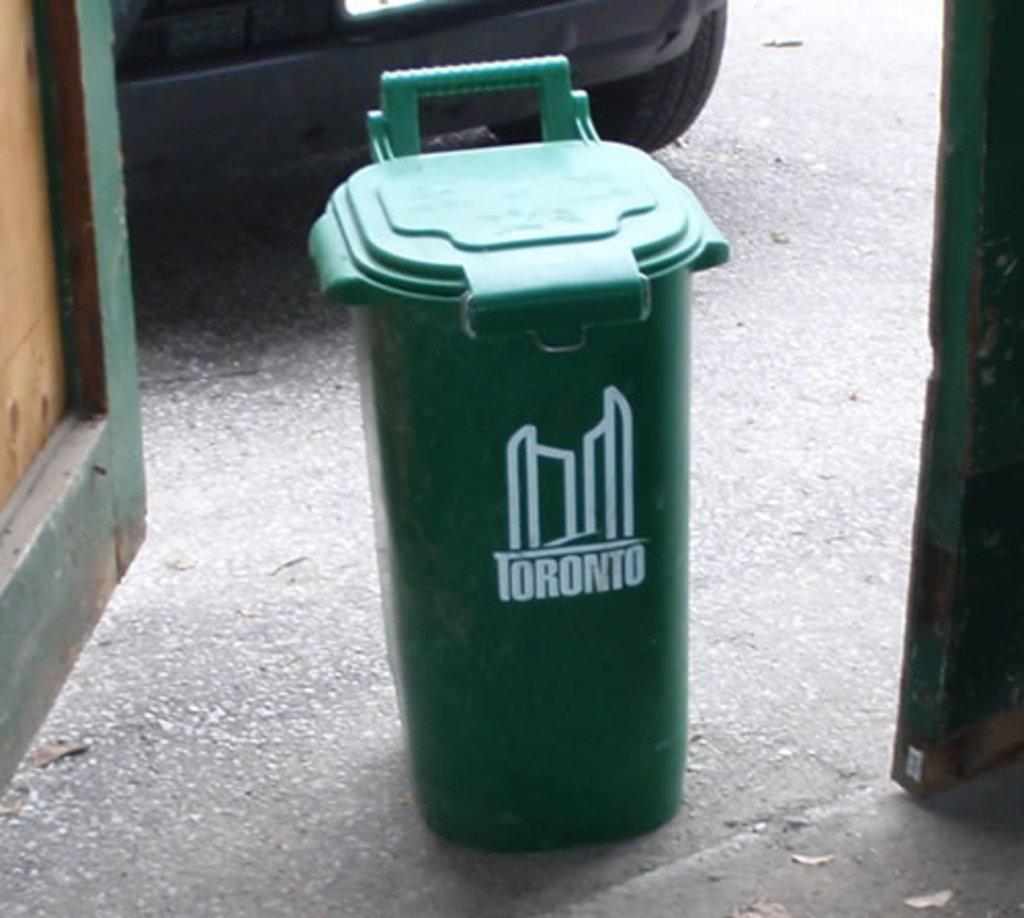Provide a one-sentence caption for the provided image. a green Toronto trash can outside on the pavement. 